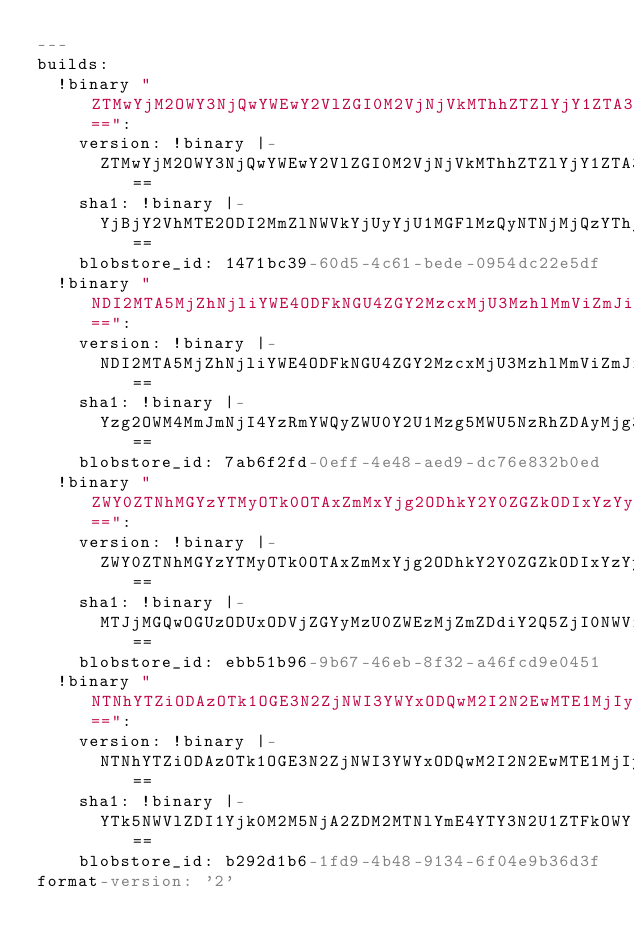<code> <loc_0><loc_0><loc_500><loc_500><_YAML_>---
builds:
  !binary "ZTMwYjM2OWY3NjQwYWEwY2VlZGI0M2VjNjVkMThhZTZlYjY1ZTA3Ng==":
    version: !binary |-
      ZTMwYjM2OWY3NjQwYWEwY2VlZGI0M2VjNjVkMThhZTZlYjY1ZTA3Ng==
    sha1: !binary |-
      YjBjY2VhMTE2ODI2MmZlNWVkYjUyYjU1MGFlMzQyNTNjMjQzYThjNg==
    blobstore_id: 1471bc39-60d5-4c61-bede-0954dc22e5df
  !binary "NDI2MTA5MjZhNjliYWE4ODFkNGU4ZGY2MzcxMjU3MzhlMmViZmJiNQ==":
    version: !binary |-
      NDI2MTA5MjZhNjliYWE4ODFkNGU4ZGY2MzcxMjU3MzhlMmViZmJiNQ==
    sha1: !binary |-
      Yzg2OWM4MmJmNjI4YzRmYWQyZWU0Y2U1Mzg5MWU5NzRhZDAyMjg3OA==
    blobstore_id: 7ab6f2fd-0eff-4e48-aed9-dc76e832b0ed
  !binary "ZWY0ZTNhMGYzYTMyOTk0OTAxZmMxYjg2ODhkY2Y0ZGZkODIxYzYyMw==":
    version: !binary |-
      ZWY0ZTNhMGYzYTMyOTk0OTAxZmMxYjg2ODhkY2Y0ZGZkODIxYzYyMw==
    sha1: !binary |-
      MTJjMGQwOGUzODUxODVjZGYyMzU0ZWEzMjZmZDdiY2Q5ZjI0NWViZA==
    blobstore_id: ebb51b96-9b67-46eb-8f32-a46fcd9e0451
  !binary "NTNhYTZiODAzOTk1OGE3N2ZjNWI3YWYxODQwM2I2N2EwMTE1MjIyOQ==":
    version: !binary |-
      NTNhYTZiODAzOTk1OGE3N2ZjNWI3YWYxODQwM2I2N2EwMTE1MjIyOQ==
    sha1: !binary |-
      YTk5NWVlZDI1Yjk0M2M5NjA2ZDM2MTNlYmE4YTY3N2U1ZTFkOWY1OA==
    blobstore_id: b292d1b6-1fd9-4b48-9134-6f04e9b36d3f
format-version: '2'
</code> 